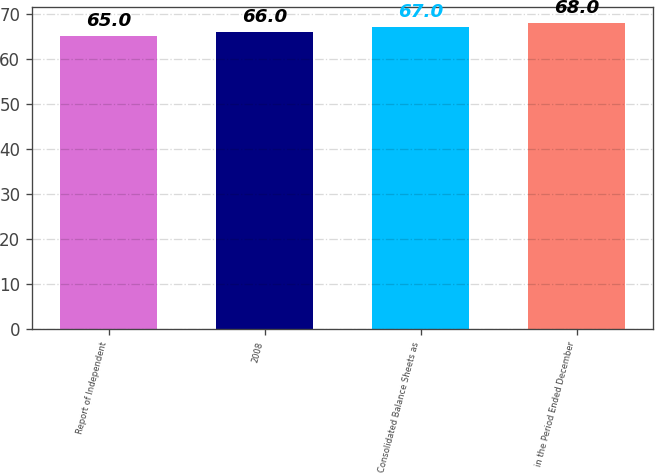<chart> <loc_0><loc_0><loc_500><loc_500><bar_chart><fcel>Report of Independent<fcel>2008<fcel>Consolidated Balance Sheets as<fcel>in the Period Ended December<nl><fcel>65<fcel>66<fcel>67<fcel>68<nl></chart> 